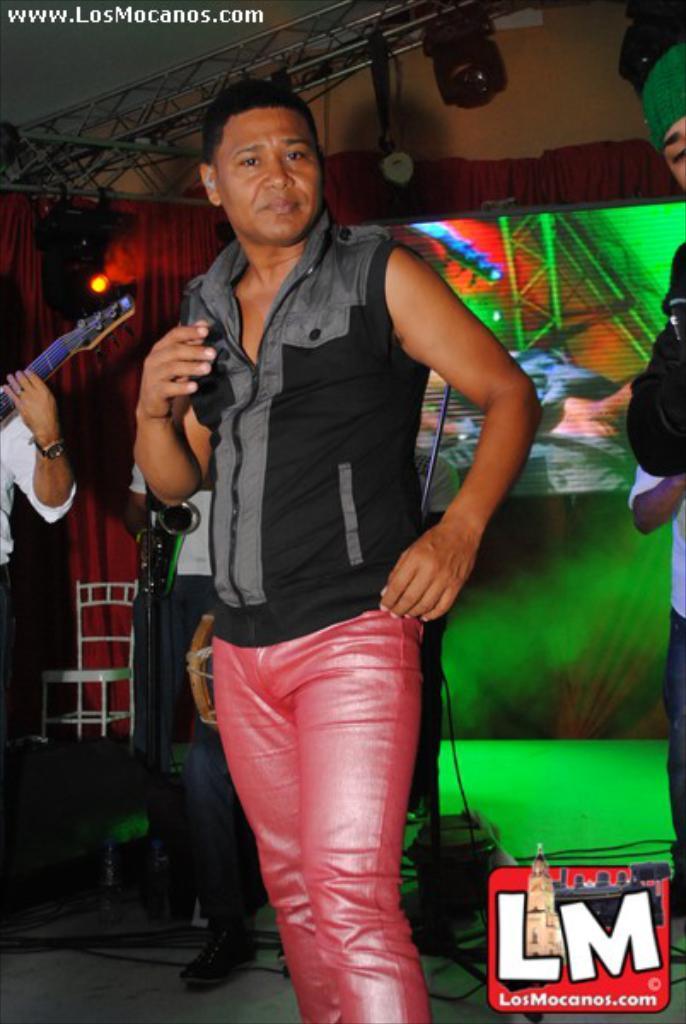In one or two sentences, can you explain what this image depicts? A man is there, he wore black color t-shirt. On the right side there is a mark. 